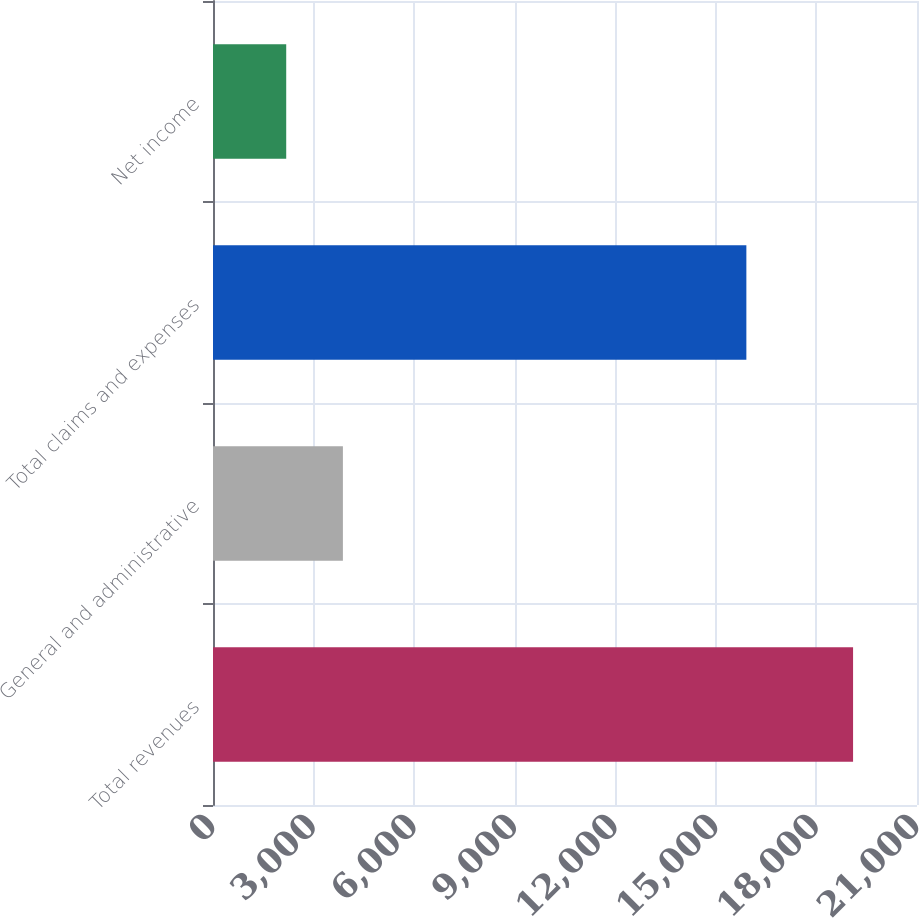<chart> <loc_0><loc_0><loc_500><loc_500><bar_chart><fcel>Total revenues<fcel>General and administrative<fcel>Total claims and expenses<fcel>Net income<nl><fcel>19093<fcel>3874.9<fcel>15910<fcel>2184<nl></chart> 